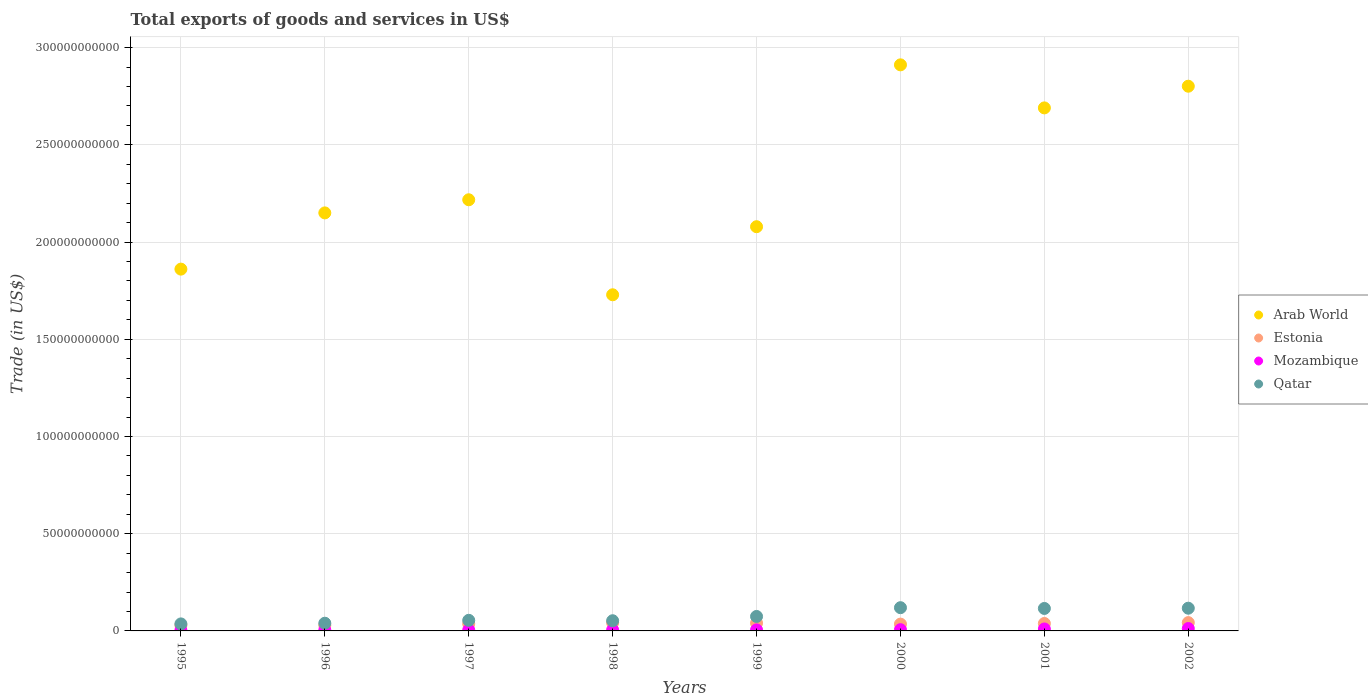How many different coloured dotlines are there?
Provide a succinct answer. 4. What is the total exports of goods and services in Mozambique in 2000?
Your answer should be compact. 6.44e+08. Across all years, what is the maximum total exports of goods and services in Estonia?
Keep it short and to the point. 4.27e+09. Across all years, what is the minimum total exports of goods and services in Mozambique?
Provide a succinct answer. 3.33e+08. In which year was the total exports of goods and services in Estonia minimum?
Your response must be concise. 1996. What is the total total exports of goods and services in Qatar in the graph?
Offer a terse response. 6.09e+1. What is the difference between the total exports of goods and services in Arab World in 1995 and that in 1996?
Give a very brief answer. -2.89e+1. What is the difference between the total exports of goods and services in Arab World in 2002 and the total exports of goods and services in Qatar in 1999?
Ensure brevity in your answer.  2.73e+11. What is the average total exports of goods and services in Estonia per year?
Your answer should be compact. 3.67e+09. In the year 1999, what is the difference between the total exports of goods and services in Qatar and total exports of goods and services in Mozambique?
Your answer should be very brief. 6.90e+09. In how many years, is the total exports of goods and services in Arab World greater than 110000000000 US$?
Offer a terse response. 8. What is the ratio of the total exports of goods and services in Qatar in 2000 to that in 2001?
Your answer should be compact. 1.03. What is the difference between the highest and the second highest total exports of goods and services in Arab World?
Ensure brevity in your answer.  1.10e+1. What is the difference between the highest and the lowest total exports of goods and services in Arab World?
Provide a succinct answer. 1.18e+11. Does the total exports of goods and services in Mozambique monotonically increase over the years?
Your response must be concise. Yes. Is the total exports of goods and services in Mozambique strictly greater than the total exports of goods and services in Estonia over the years?
Ensure brevity in your answer.  No. Is the total exports of goods and services in Mozambique strictly less than the total exports of goods and services in Qatar over the years?
Provide a succinct answer. Yes. What is the difference between two consecutive major ticks on the Y-axis?
Give a very brief answer. 5.00e+1. How many legend labels are there?
Make the answer very short. 4. How are the legend labels stacked?
Offer a very short reply. Vertical. What is the title of the graph?
Make the answer very short. Total exports of goods and services in US$. What is the label or title of the Y-axis?
Offer a very short reply. Trade (in US$). What is the Trade (in US$) of Arab World in 1995?
Your response must be concise. 1.86e+11. What is the Trade (in US$) of Estonia in 1995?
Your answer should be very brief. 2.97e+09. What is the Trade (in US$) in Mozambique in 1995?
Your answer should be compact. 3.33e+08. What is the Trade (in US$) in Qatar in 1995?
Provide a short and direct response. 3.61e+09. What is the Trade (in US$) of Arab World in 1996?
Make the answer very short. 2.15e+11. What is the Trade (in US$) in Estonia in 1996?
Keep it short and to the point. 2.93e+09. What is the Trade (in US$) of Mozambique in 1996?
Offer a very short reply. 4.64e+08. What is the Trade (in US$) of Qatar in 1996?
Your response must be concise. 3.96e+09. What is the Trade (in US$) in Arab World in 1997?
Give a very brief answer. 2.22e+11. What is the Trade (in US$) in Estonia in 1997?
Keep it short and to the point. 3.63e+09. What is the Trade (in US$) in Mozambique in 1997?
Your response must be concise. 5.08e+08. What is the Trade (in US$) in Qatar in 1997?
Provide a succinct answer. 5.45e+09. What is the Trade (in US$) of Arab World in 1998?
Make the answer very short. 1.73e+11. What is the Trade (in US$) in Estonia in 1998?
Your answer should be very brief. 4.18e+09. What is the Trade (in US$) of Mozambique in 1998?
Your answer should be compact. 5.33e+08. What is the Trade (in US$) of Qatar in 1998?
Provide a succinct answer. 5.24e+09. What is the Trade (in US$) of Arab World in 1999?
Provide a succinct answer. 2.08e+11. What is the Trade (in US$) of Estonia in 1999?
Provide a short and direct response. 4.02e+09. What is the Trade (in US$) of Mozambique in 1999?
Keep it short and to the point. 5.39e+08. What is the Trade (in US$) of Qatar in 1999?
Make the answer very short. 7.44e+09. What is the Trade (in US$) in Arab World in 2000?
Your answer should be very brief. 2.91e+11. What is the Trade (in US$) in Estonia in 2000?
Your answer should be compact. 3.50e+09. What is the Trade (in US$) in Mozambique in 2000?
Provide a succinct answer. 6.44e+08. What is the Trade (in US$) in Qatar in 2000?
Provide a short and direct response. 1.19e+1. What is the Trade (in US$) in Arab World in 2001?
Provide a short and direct response. 2.69e+11. What is the Trade (in US$) of Estonia in 2001?
Offer a terse response. 3.83e+09. What is the Trade (in US$) of Mozambique in 2001?
Offer a very short reply. 1.01e+09. What is the Trade (in US$) in Qatar in 2001?
Provide a short and direct response. 1.16e+1. What is the Trade (in US$) of Arab World in 2002?
Ensure brevity in your answer.  2.80e+11. What is the Trade (in US$) in Estonia in 2002?
Offer a very short reply. 4.27e+09. What is the Trade (in US$) of Mozambique in 2002?
Your answer should be very brief. 1.23e+09. What is the Trade (in US$) of Qatar in 2002?
Ensure brevity in your answer.  1.17e+1. Across all years, what is the maximum Trade (in US$) of Arab World?
Give a very brief answer. 2.91e+11. Across all years, what is the maximum Trade (in US$) of Estonia?
Your answer should be very brief. 4.27e+09. Across all years, what is the maximum Trade (in US$) of Mozambique?
Keep it short and to the point. 1.23e+09. Across all years, what is the maximum Trade (in US$) in Qatar?
Keep it short and to the point. 1.19e+1. Across all years, what is the minimum Trade (in US$) in Arab World?
Keep it short and to the point. 1.73e+11. Across all years, what is the minimum Trade (in US$) of Estonia?
Make the answer very short. 2.93e+09. Across all years, what is the minimum Trade (in US$) in Mozambique?
Offer a terse response. 3.33e+08. Across all years, what is the minimum Trade (in US$) in Qatar?
Offer a terse response. 3.61e+09. What is the total Trade (in US$) of Arab World in the graph?
Offer a very short reply. 1.84e+12. What is the total Trade (in US$) in Estonia in the graph?
Make the answer very short. 2.93e+1. What is the total Trade (in US$) in Mozambique in the graph?
Make the answer very short. 5.26e+09. What is the total Trade (in US$) in Qatar in the graph?
Your answer should be compact. 6.09e+1. What is the difference between the Trade (in US$) in Arab World in 1995 and that in 1996?
Offer a very short reply. -2.89e+1. What is the difference between the Trade (in US$) of Estonia in 1995 and that in 1996?
Make the answer very short. 3.47e+07. What is the difference between the Trade (in US$) in Mozambique in 1995 and that in 1996?
Offer a terse response. -1.31e+08. What is the difference between the Trade (in US$) of Qatar in 1995 and that in 1996?
Ensure brevity in your answer.  -3.53e+08. What is the difference between the Trade (in US$) of Arab World in 1995 and that in 1997?
Provide a succinct answer. -3.57e+1. What is the difference between the Trade (in US$) in Estonia in 1995 and that in 1997?
Provide a short and direct response. -6.60e+08. What is the difference between the Trade (in US$) of Mozambique in 1995 and that in 1997?
Keep it short and to the point. -1.74e+08. What is the difference between the Trade (in US$) of Qatar in 1995 and that in 1997?
Keep it short and to the point. -1.85e+09. What is the difference between the Trade (in US$) of Arab World in 1995 and that in 1998?
Provide a succinct answer. 1.32e+1. What is the difference between the Trade (in US$) in Estonia in 1995 and that in 1998?
Make the answer very short. -1.21e+09. What is the difference between the Trade (in US$) of Mozambique in 1995 and that in 1998?
Your response must be concise. -1.99e+08. What is the difference between the Trade (in US$) in Qatar in 1995 and that in 1998?
Offer a very short reply. -1.63e+09. What is the difference between the Trade (in US$) of Arab World in 1995 and that in 1999?
Ensure brevity in your answer.  -2.18e+1. What is the difference between the Trade (in US$) in Estonia in 1995 and that in 1999?
Ensure brevity in your answer.  -1.05e+09. What is the difference between the Trade (in US$) of Mozambique in 1995 and that in 1999?
Keep it short and to the point. -2.06e+08. What is the difference between the Trade (in US$) of Qatar in 1995 and that in 1999?
Provide a short and direct response. -3.83e+09. What is the difference between the Trade (in US$) in Arab World in 1995 and that in 2000?
Make the answer very short. -1.05e+11. What is the difference between the Trade (in US$) in Estonia in 1995 and that in 2000?
Make the answer very short. -5.37e+08. What is the difference between the Trade (in US$) in Mozambique in 1995 and that in 2000?
Offer a very short reply. -3.10e+08. What is the difference between the Trade (in US$) in Qatar in 1995 and that in 2000?
Your answer should be compact. -8.34e+09. What is the difference between the Trade (in US$) of Arab World in 1995 and that in 2001?
Provide a succinct answer. -8.29e+1. What is the difference between the Trade (in US$) of Estonia in 1995 and that in 2001?
Your answer should be very brief. -8.64e+08. What is the difference between the Trade (in US$) in Mozambique in 1995 and that in 2001?
Your response must be concise. -6.73e+08. What is the difference between the Trade (in US$) in Qatar in 1995 and that in 2001?
Provide a succinct answer. -7.95e+09. What is the difference between the Trade (in US$) in Arab World in 1995 and that in 2002?
Your response must be concise. -9.41e+1. What is the difference between the Trade (in US$) of Estonia in 1995 and that in 2002?
Offer a very short reply. -1.30e+09. What is the difference between the Trade (in US$) of Mozambique in 1995 and that in 2002?
Your answer should be compact. -8.95e+08. What is the difference between the Trade (in US$) in Qatar in 1995 and that in 2002?
Keep it short and to the point. -8.08e+09. What is the difference between the Trade (in US$) in Arab World in 1996 and that in 1997?
Keep it short and to the point. -6.75e+09. What is the difference between the Trade (in US$) of Estonia in 1996 and that in 1997?
Make the answer very short. -6.95e+08. What is the difference between the Trade (in US$) in Mozambique in 1996 and that in 1997?
Give a very brief answer. -4.33e+07. What is the difference between the Trade (in US$) of Qatar in 1996 and that in 1997?
Keep it short and to the point. -1.49e+09. What is the difference between the Trade (in US$) in Arab World in 1996 and that in 1998?
Your answer should be compact. 4.21e+1. What is the difference between the Trade (in US$) in Estonia in 1996 and that in 1998?
Provide a short and direct response. -1.25e+09. What is the difference between the Trade (in US$) in Mozambique in 1996 and that in 1998?
Your answer should be very brief. -6.84e+07. What is the difference between the Trade (in US$) in Qatar in 1996 and that in 1998?
Your answer should be compact. -1.28e+09. What is the difference between the Trade (in US$) in Arab World in 1996 and that in 1999?
Offer a very short reply. 7.10e+09. What is the difference between the Trade (in US$) in Estonia in 1996 and that in 1999?
Give a very brief answer. -1.09e+09. What is the difference between the Trade (in US$) in Mozambique in 1996 and that in 1999?
Offer a terse response. -7.48e+07. What is the difference between the Trade (in US$) in Qatar in 1996 and that in 1999?
Your response must be concise. -3.48e+09. What is the difference between the Trade (in US$) of Arab World in 1996 and that in 2000?
Keep it short and to the point. -7.61e+1. What is the difference between the Trade (in US$) in Estonia in 1996 and that in 2000?
Offer a terse response. -5.72e+08. What is the difference between the Trade (in US$) in Mozambique in 1996 and that in 2000?
Ensure brevity in your answer.  -1.79e+08. What is the difference between the Trade (in US$) of Qatar in 1996 and that in 2000?
Ensure brevity in your answer.  -7.99e+09. What is the difference between the Trade (in US$) of Arab World in 1996 and that in 2001?
Your answer should be compact. -5.40e+1. What is the difference between the Trade (in US$) of Estonia in 1996 and that in 2001?
Your answer should be very brief. -8.98e+08. What is the difference between the Trade (in US$) of Mozambique in 1996 and that in 2001?
Keep it short and to the point. -5.42e+08. What is the difference between the Trade (in US$) of Qatar in 1996 and that in 2001?
Make the answer very short. -7.60e+09. What is the difference between the Trade (in US$) in Arab World in 1996 and that in 2002?
Give a very brief answer. -6.52e+1. What is the difference between the Trade (in US$) in Estonia in 1996 and that in 2002?
Make the answer very short. -1.34e+09. What is the difference between the Trade (in US$) in Mozambique in 1996 and that in 2002?
Ensure brevity in your answer.  -7.64e+08. What is the difference between the Trade (in US$) in Qatar in 1996 and that in 2002?
Your answer should be very brief. -7.72e+09. What is the difference between the Trade (in US$) in Arab World in 1997 and that in 1998?
Provide a succinct answer. 4.89e+1. What is the difference between the Trade (in US$) of Estonia in 1997 and that in 1998?
Your answer should be very brief. -5.50e+08. What is the difference between the Trade (in US$) in Mozambique in 1997 and that in 1998?
Ensure brevity in your answer.  -2.51e+07. What is the difference between the Trade (in US$) of Qatar in 1997 and that in 1998?
Offer a terse response. 2.15e+08. What is the difference between the Trade (in US$) in Arab World in 1997 and that in 1999?
Your answer should be compact. 1.39e+1. What is the difference between the Trade (in US$) in Estonia in 1997 and that in 1999?
Make the answer very short. -3.94e+08. What is the difference between the Trade (in US$) in Mozambique in 1997 and that in 1999?
Provide a short and direct response. -3.15e+07. What is the difference between the Trade (in US$) of Qatar in 1997 and that in 1999?
Offer a terse response. -1.99e+09. What is the difference between the Trade (in US$) of Arab World in 1997 and that in 2000?
Ensure brevity in your answer.  -6.94e+1. What is the difference between the Trade (in US$) in Estonia in 1997 and that in 2000?
Offer a very short reply. 1.23e+08. What is the difference between the Trade (in US$) in Mozambique in 1997 and that in 2000?
Keep it short and to the point. -1.36e+08. What is the difference between the Trade (in US$) in Qatar in 1997 and that in 2000?
Provide a short and direct response. -6.49e+09. What is the difference between the Trade (in US$) in Arab World in 1997 and that in 2001?
Your answer should be very brief. -4.73e+1. What is the difference between the Trade (in US$) of Estonia in 1997 and that in 2001?
Ensure brevity in your answer.  -2.03e+08. What is the difference between the Trade (in US$) of Mozambique in 1997 and that in 2001?
Offer a very short reply. -4.99e+08. What is the difference between the Trade (in US$) in Qatar in 1997 and that in 2001?
Provide a short and direct response. -6.10e+09. What is the difference between the Trade (in US$) of Arab World in 1997 and that in 2002?
Give a very brief answer. -5.84e+1. What is the difference between the Trade (in US$) of Estonia in 1997 and that in 2002?
Make the answer very short. -6.42e+08. What is the difference between the Trade (in US$) in Mozambique in 1997 and that in 2002?
Your answer should be compact. -7.21e+08. What is the difference between the Trade (in US$) in Qatar in 1997 and that in 2002?
Your answer should be compact. -6.23e+09. What is the difference between the Trade (in US$) in Arab World in 1998 and that in 1999?
Keep it short and to the point. -3.50e+1. What is the difference between the Trade (in US$) of Estonia in 1998 and that in 1999?
Provide a short and direct response. 1.56e+08. What is the difference between the Trade (in US$) of Mozambique in 1998 and that in 1999?
Your answer should be very brief. -6.35e+06. What is the difference between the Trade (in US$) of Qatar in 1998 and that in 1999?
Offer a terse response. -2.20e+09. What is the difference between the Trade (in US$) in Arab World in 1998 and that in 2000?
Make the answer very short. -1.18e+11. What is the difference between the Trade (in US$) of Estonia in 1998 and that in 2000?
Provide a short and direct response. 6.74e+08. What is the difference between the Trade (in US$) in Mozambique in 1998 and that in 2000?
Your answer should be very brief. -1.11e+08. What is the difference between the Trade (in US$) in Qatar in 1998 and that in 2000?
Your response must be concise. -6.71e+09. What is the difference between the Trade (in US$) of Arab World in 1998 and that in 2001?
Your answer should be very brief. -9.61e+1. What is the difference between the Trade (in US$) in Estonia in 1998 and that in 2001?
Offer a very short reply. 3.47e+08. What is the difference between the Trade (in US$) in Mozambique in 1998 and that in 2001?
Your response must be concise. -4.74e+08. What is the difference between the Trade (in US$) of Qatar in 1998 and that in 2001?
Give a very brief answer. -6.32e+09. What is the difference between the Trade (in US$) of Arab World in 1998 and that in 2002?
Your answer should be very brief. -1.07e+11. What is the difference between the Trade (in US$) in Estonia in 1998 and that in 2002?
Ensure brevity in your answer.  -9.21e+07. What is the difference between the Trade (in US$) of Mozambique in 1998 and that in 2002?
Keep it short and to the point. -6.96e+08. What is the difference between the Trade (in US$) of Qatar in 1998 and that in 2002?
Make the answer very short. -6.44e+09. What is the difference between the Trade (in US$) of Arab World in 1999 and that in 2000?
Provide a short and direct response. -8.32e+1. What is the difference between the Trade (in US$) in Estonia in 1999 and that in 2000?
Offer a very short reply. 5.18e+08. What is the difference between the Trade (in US$) of Mozambique in 1999 and that in 2000?
Ensure brevity in your answer.  -1.05e+08. What is the difference between the Trade (in US$) of Qatar in 1999 and that in 2000?
Provide a succinct answer. -4.51e+09. What is the difference between the Trade (in US$) in Arab World in 1999 and that in 2001?
Offer a terse response. -6.11e+1. What is the difference between the Trade (in US$) in Estonia in 1999 and that in 2001?
Ensure brevity in your answer.  1.91e+08. What is the difference between the Trade (in US$) of Mozambique in 1999 and that in 2001?
Give a very brief answer. -4.68e+08. What is the difference between the Trade (in US$) of Qatar in 1999 and that in 2001?
Offer a terse response. -4.12e+09. What is the difference between the Trade (in US$) in Arab World in 1999 and that in 2002?
Your answer should be very brief. -7.23e+1. What is the difference between the Trade (in US$) in Estonia in 1999 and that in 2002?
Your answer should be very brief. -2.48e+08. What is the difference between the Trade (in US$) of Mozambique in 1999 and that in 2002?
Ensure brevity in your answer.  -6.89e+08. What is the difference between the Trade (in US$) in Qatar in 1999 and that in 2002?
Offer a very short reply. -4.24e+09. What is the difference between the Trade (in US$) in Arab World in 2000 and that in 2001?
Provide a succinct answer. 2.21e+1. What is the difference between the Trade (in US$) in Estonia in 2000 and that in 2001?
Ensure brevity in your answer.  -3.27e+08. What is the difference between the Trade (in US$) of Mozambique in 2000 and that in 2001?
Keep it short and to the point. -3.63e+08. What is the difference between the Trade (in US$) of Qatar in 2000 and that in 2001?
Give a very brief answer. 3.93e+08. What is the difference between the Trade (in US$) of Arab World in 2000 and that in 2002?
Ensure brevity in your answer.  1.10e+1. What is the difference between the Trade (in US$) of Estonia in 2000 and that in 2002?
Keep it short and to the point. -7.66e+08. What is the difference between the Trade (in US$) of Mozambique in 2000 and that in 2002?
Your answer should be compact. -5.85e+08. What is the difference between the Trade (in US$) of Qatar in 2000 and that in 2002?
Your answer should be compact. 2.65e+08. What is the difference between the Trade (in US$) of Arab World in 2001 and that in 2002?
Provide a succinct answer. -1.12e+1. What is the difference between the Trade (in US$) in Estonia in 2001 and that in 2002?
Offer a very short reply. -4.39e+08. What is the difference between the Trade (in US$) of Mozambique in 2001 and that in 2002?
Offer a very short reply. -2.22e+08. What is the difference between the Trade (in US$) in Qatar in 2001 and that in 2002?
Provide a short and direct response. -1.28e+08. What is the difference between the Trade (in US$) of Arab World in 1995 and the Trade (in US$) of Estonia in 1996?
Provide a short and direct response. 1.83e+11. What is the difference between the Trade (in US$) in Arab World in 1995 and the Trade (in US$) in Mozambique in 1996?
Ensure brevity in your answer.  1.86e+11. What is the difference between the Trade (in US$) of Arab World in 1995 and the Trade (in US$) of Qatar in 1996?
Provide a succinct answer. 1.82e+11. What is the difference between the Trade (in US$) in Estonia in 1995 and the Trade (in US$) in Mozambique in 1996?
Offer a very short reply. 2.50e+09. What is the difference between the Trade (in US$) in Estonia in 1995 and the Trade (in US$) in Qatar in 1996?
Offer a very short reply. -9.94e+08. What is the difference between the Trade (in US$) of Mozambique in 1995 and the Trade (in US$) of Qatar in 1996?
Keep it short and to the point. -3.63e+09. What is the difference between the Trade (in US$) in Arab World in 1995 and the Trade (in US$) in Estonia in 1997?
Your response must be concise. 1.82e+11. What is the difference between the Trade (in US$) of Arab World in 1995 and the Trade (in US$) of Mozambique in 1997?
Make the answer very short. 1.86e+11. What is the difference between the Trade (in US$) in Arab World in 1995 and the Trade (in US$) in Qatar in 1997?
Your answer should be compact. 1.81e+11. What is the difference between the Trade (in US$) in Estonia in 1995 and the Trade (in US$) in Mozambique in 1997?
Provide a succinct answer. 2.46e+09. What is the difference between the Trade (in US$) of Estonia in 1995 and the Trade (in US$) of Qatar in 1997?
Offer a very short reply. -2.49e+09. What is the difference between the Trade (in US$) in Mozambique in 1995 and the Trade (in US$) in Qatar in 1997?
Your answer should be very brief. -5.12e+09. What is the difference between the Trade (in US$) in Arab World in 1995 and the Trade (in US$) in Estonia in 1998?
Offer a very short reply. 1.82e+11. What is the difference between the Trade (in US$) of Arab World in 1995 and the Trade (in US$) of Mozambique in 1998?
Ensure brevity in your answer.  1.86e+11. What is the difference between the Trade (in US$) of Arab World in 1995 and the Trade (in US$) of Qatar in 1998?
Provide a succinct answer. 1.81e+11. What is the difference between the Trade (in US$) of Estonia in 1995 and the Trade (in US$) of Mozambique in 1998?
Offer a very short reply. 2.43e+09. What is the difference between the Trade (in US$) of Estonia in 1995 and the Trade (in US$) of Qatar in 1998?
Ensure brevity in your answer.  -2.27e+09. What is the difference between the Trade (in US$) of Mozambique in 1995 and the Trade (in US$) of Qatar in 1998?
Provide a succinct answer. -4.91e+09. What is the difference between the Trade (in US$) of Arab World in 1995 and the Trade (in US$) of Estonia in 1999?
Provide a short and direct response. 1.82e+11. What is the difference between the Trade (in US$) in Arab World in 1995 and the Trade (in US$) in Mozambique in 1999?
Your answer should be compact. 1.86e+11. What is the difference between the Trade (in US$) in Arab World in 1995 and the Trade (in US$) in Qatar in 1999?
Make the answer very short. 1.79e+11. What is the difference between the Trade (in US$) in Estonia in 1995 and the Trade (in US$) in Mozambique in 1999?
Your response must be concise. 2.43e+09. What is the difference between the Trade (in US$) in Estonia in 1995 and the Trade (in US$) in Qatar in 1999?
Make the answer very short. -4.47e+09. What is the difference between the Trade (in US$) in Mozambique in 1995 and the Trade (in US$) in Qatar in 1999?
Provide a short and direct response. -7.11e+09. What is the difference between the Trade (in US$) in Arab World in 1995 and the Trade (in US$) in Estonia in 2000?
Offer a terse response. 1.83e+11. What is the difference between the Trade (in US$) in Arab World in 1995 and the Trade (in US$) in Mozambique in 2000?
Offer a terse response. 1.85e+11. What is the difference between the Trade (in US$) of Arab World in 1995 and the Trade (in US$) of Qatar in 2000?
Keep it short and to the point. 1.74e+11. What is the difference between the Trade (in US$) in Estonia in 1995 and the Trade (in US$) in Mozambique in 2000?
Your answer should be very brief. 2.32e+09. What is the difference between the Trade (in US$) of Estonia in 1995 and the Trade (in US$) of Qatar in 2000?
Provide a succinct answer. -8.98e+09. What is the difference between the Trade (in US$) in Mozambique in 1995 and the Trade (in US$) in Qatar in 2000?
Offer a terse response. -1.16e+1. What is the difference between the Trade (in US$) in Arab World in 1995 and the Trade (in US$) in Estonia in 2001?
Keep it short and to the point. 1.82e+11. What is the difference between the Trade (in US$) of Arab World in 1995 and the Trade (in US$) of Mozambique in 2001?
Provide a short and direct response. 1.85e+11. What is the difference between the Trade (in US$) of Arab World in 1995 and the Trade (in US$) of Qatar in 2001?
Your response must be concise. 1.75e+11. What is the difference between the Trade (in US$) in Estonia in 1995 and the Trade (in US$) in Mozambique in 2001?
Your response must be concise. 1.96e+09. What is the difference between the Trade (in US$) in Estonia in 1995 and the Trade (in US$) in Qatar in 2001?
Your answer should be compact. -8.59e+09. What is the difference between the Trade (in US$) in Mozambique in 1995 and the Trade (in US$) in Qatar in 2001?
Ensure brevity in your answer.  -1.12e+1. What is the difference between the Trade (in US$) in Arab World in 1995 and the Trade (in US$) in Estonia in 2002?
Offer a very short reply. 1.82e+11. What is the difference between the Trade (in US$) of Arab World in 1995 and the Trade (in US$) of Mozambique in 2002?
Ensure brevity in your answer.  1.85e+11. What is the difference between the Trade (in US$) of Arab World in 1995 and the Trade (in US$) of Qatar in 2002?
Your answer should be compact. 1.74e+11. What is the difference between the Trade (in US$) in Estonia in 1995 and the Trade (in US$) in Mozambique in 2002?
Offer a terse response. 1.74e+09. What is the difference between the Trade (in US$) of Estonia in 1995 and the Trade (in US$) of Qatar in 2002?
Offer a terse response. -8.72e+09. What is the difference between the Trade (in US$) of Mozambique in 1995 and the Trade (in US$) of Qatar in 2002?
Offer a very short reply. -1.14e+1. What is the difference between the Trade (in US$) of Arab World in 1996 and the Trade (in US$) of Estonia in 1997?
Provide a short and direct response. 2.11e+11. What is the difference between the Trade (in US$) of Arab World in 1996 and the Trade (in US$) of Mozambique in 1997?
Give a very brief answer. 2.14e+11. What is the difference between the Trade (in US$) in Arab World in 1996 and the Trade (in US$) in Qatar in 1997?
Keep it short and to the point. 2.10e+11. What is the difference between the Trade (in US$) in Estonia in 1996 and the Trade (in US$) in Mozambique in 1997?
Provide a short and direct response. 2.43e+09. What is the difference between the Trade (in US$) in Estonia in 1996 and the Trade (in US$) in Qatar in 1997?
Your answer should be very brief. -2.52e+09. What is the difference between the Trade (in US$) of Mozambique in 1996 and the Trade (in US$) of Qatar in 1997?
Your response must be concise. -4.99e+09. What is the difference between the Trade (in US$) in Arab World in 1996 and the Trade (in US$) in Estonia in 1998?
Provide a succinct answer. 2.11e+11. What is the difference between the Trade (in US$) in Arab World in 1996 and the Trade (in US$) in Mozambique in 1998?
Give a very brief answer. 2.14e+11. What is the difference between the Trade (in US$) of Arab World in 1996 and the Trade (in US$) of Qatar in 1998?
Provide a short and direct response. 2.10e+11. What is the difference between the Trade (in US$) in Estonia in 1996 and the Trade (in US$) in Mozambique in 1998?
Provide a succinct answer. 2.40e+09. What is the difference between the Trade (in US$) in Estonia in 1996 and the Trade (in US$) in Qatar in 1998?
Make the answer very short. -2.31e+09. What is the difference between the Trade (in US$) of Mozambique in 1996 and the Trade (in US$) of Qatar in 1998?
Provide a short and direct response. -4.78e+09. What is the difference between the Trade (in US$) in Arab World in 1996 and the Trade (in US$) in Estonia in 1999?
Make the answer very short. 2.11e+11. What is the difference between the Trade (in US$) in Arab World in 1996 and the Trade (in US$) in Mozambique in 1999?
Provide a short and direct response. 2.14e+11. What is the difference between the Trade (in US$) of Arab World in 1996 and the Trade (in US$) of Qatar in 1999?
Give a very brief answer. 2.08e+11. What is the difference between the Trade (in US$) of Estonia in 1996 and the Trade (in US$) of Mozambique in 1999?
Ensure brevity in your answer.  2.39e+09. What is the difference between the Trade (in US$) of Estonia in 1996 and the Trade (in US$) of Qatar in 1999?
Ensure brevity in your answer.  -4.51e+09. What is the difference between the Trade (in US$) of Mozambique in 1996 and the Trade (in US$) of Qatar in 1999?
Your response must be concise. -6.98e+09. What is the difference between the Trade (in US$) of Arab World in 1996 and the Trade (in US$) of Estonia in 2000?
Ensure brevity in your answer.  2.11e+11. What is the difference between the Trade (in US$) in Arab World in 1996 and the Trade (in US$) in Mozambique in 2000?
Give a very brief answer. 2.14e+11. What is the difference between the Trade (in US$) in Arab World in 1996 and the Trade (in US$) in Qatar in 2000?
Make the answer very short. 2.03e+11. What is the difference between the Trade (in US$) of Estonia in 1996 and the Trade (in US$) of Mozambique in 2000?
Your answer should be compact. 2.29e+09. What is the difference between the Trade (in US$) in Estonia in 1996 and the Trade (in US$) in Qatar in 2000?
Offer a terse response. -9.02e+09. What is the difference between the Trade (in US$) in Mozambique in 1996 and the Trade (in US$) in Qatar in 2000?
Offer a very short reply. -1.15e+1. What is the difference between the Trade (in US$) in Arab World in 1996 and the Trade (in US$) in Estonia in 2001?
Your answer should be very brief. 2.11e+11. What is the difference between the Trade (in US$) in Arab World in 1996 and the Trade (in US$) in Mozambique in 2001?
Give a very brief answer. 2.14e+11. What is the difference between the Trade (in US$) in Arab World in 1996 and the Trade (in US$) in Qatar in 2001?
Ensure brevity in your answer.  2.03e+11. What is the difference between the Trade (in US$) of Estonia in 1996 and the Trade (in US$) of Mozambique in 2001?
Your answer should be very brief. 1.93e+09. What is the difference between the Trade (in US$) in Estonia in 1996 and the Trade (in US$) in Qatar in 2001?
Provide a short and direct response. -8.62e+09. What is the difference between the Trade (in US$) in Mozambique in 1996 and the Trade (in US$) in Qatar in 2001?
Provide a succinct answer. -1.11e+1. What is the difference between the Trade (in US$) of Arab World in 1996 and the Trade (in US$) of Estonia in 2002?
Make the answer very short. 2.11e+11. What is the difference between the Trade (in US$) in Arab World in 1996 and the Trade (in US$) in Mozambique in 2002?
Your response must be concise. 2.14e+11. What is the difference between the Trade (in US$) of Arab World in 1996 and the Trade (in US$) of Qatar in 2002?
Your answer should be compact. 2.03e+11. What is the difference between the Trade (in US$) of Estonia in 1996 and the Trade (in US$) of Mozambique in 2002?
Ensure brevity in your answer.  1.70e+09. What is the difference between the Trade (in US$) of Estonia in 1996 and the Trade (in US$) of Qatar in 2002?
Give a very brief answer. -8.75e+09. What is the difference between the Trade (in US$) of Mozambique in 1996 and the Trade (in US$) of Qatar in 2002?
Make the answer very short. -1.12e+1. What is the difference between the Trade (in US$) of Arab World in 1997 and the Trade (in US$) of Estonia in 1998?
Offer a very short reply. 2.18e+11. What is the difference between the Trade (in US$) in Arab World in 1997 and the Trade (in US$) in Mozambique in 1998?
Offer a very short reply. 2.21e+11. What is the difference between the Trade (in US$) in Arab World in 1997 and the Trade (in US$) in Qatar in 1998?
Your answer should be very brief. 2.17e+11. What is the difference between the Trade (in US$) in Estonia in 1997 and the Trade (in US$) in Mozambique in 1998?
Your answer should be very brief. 3.10e+09. What is the difference between the Trade (in US$) of Estonia in 1997 and the Trade (in US$) of Qatar in 1998?
Give a very brief answer. -1.61e+09. What is the difference between the Trade (in US$) in Mozambique in 1997 and the Trade (in US$) in Qatar in 1998?
Provide a short and direct response. -4.73e+09. What is the difference between the Trade (in US$) in Arab World in 1997 and the Trade (in US$) in Estonia in 1999?
Make the answer very short. 2.18e+11. What is the difference between the Trade (in US$) in Arab World in 1997 and the Trade (in US$) in Mozambique in 1999?
Give a very brief answer. 2.21e+11. What is the difference between the Trade (in US$) in Arab World in 1997 and the Trade (in US$) in Qatar in 1999?
Your response must be concise. 2.14e+11. What is the difference between the Trade (in US$) of Estonia in 1997 and the Trade (in US$) of Mozambique in 1999?
Offer a terse response. 3.09e+09. What is the difference between the Trade (in US$) of Estonia in 1997 and the Trade (in US$) of Qatar in 1999?
Make the answer very short. -3.81e+09. What is the difference between the Trade (in US$) of Mozambique in 1997 and the Trade (in US$) of Qatar in 1999?
Ensure brevity in your answer.  -6.93e+09. What is the difference between the Trade (in US$) of Arab World in 1997 and the Trade (in US$) of Estonia in 2000?
Your answer should be compact. 2.18e+11. What is the difference between the Trade (in US$) of Arab World in 1997 and the Trade (in US$) of Mozambique in 2000?
Give a very brief answer. 2.21e+11. What is the difference between the Trade (in US$) in Arab World in 1997 and the Trade (in US$) in Qatar in 2000?
Your answer should be very brief. 2.10e+11. What is the difference between the Trade (in US$) of Estonia in 1997 and the Trade (in US$) of Mozambique in 2000?
Ensure brevity in your answer.  2.98e+09. What is the difference between the Trade (in US$) in Estonia in 1997 and the Trade (in US$) in Qatar in 2000?
Keep it short and to the point. -8.32e+09. What is the difference between the Trade (in US$) of Mozambique in 1997 and the Trade (in US$) of Qatar in 2000?
Provide a succinct answer. -1.14e+1. What is the difference between the Trade (in US$) in Arab World in 1997 and the Trade (in US$) in Estonia in 2001?
Make the answer very short. 2.18e+11. What is the difference between the Trade (in US$) of Arab World in 1997 and the Trade (in US$) of Mozambique in 2001?
Ensure brevity in your answer.  2.21e+11. What is the difference between the Trade (in US$) of Arab World in 1997 and the Trade (in US$) of Qatar in 2001?
Your response must be concise. 2.10e+11. What is the difference between the Trade (in US$) of Estonia in 1997 and the Trade (in US$) of Mozambique in 2001?
Offer a very short reply. 2.62e+09. What is the difference between the Trade (in US$) in Estonia in 1997 and the Trade (in US$) in Qatar in 2001?
Your answer should be very brief. -7.93e+09. What is the difference between the Trade (in US$) of Mozambique in 1997 and the Trade (in US$) of Qatar in 2001?
Provide a succinct answer. -1.10e+1. What is the difference between the Trade (in US$) of Arab World in 1997 and the Trade (in US$) of Estonia in 2002?
Your response must be concise. 2.17e+11. What is the difference between the Trade (in US$) of Arab World in 1997 and the Trade (in US$) of Mozambique in 2002?
Give a very brief answer. 2.21e+11. What is the difference between the Trade (in US$) of Arab World in 1997 and the Trade (in US$) of Qatar in 2002?
Give a very brief answer. 2.10e+11. What is the difference between the Trade (in US$) of Estonia in 1997 and the Trade (in US$) of Mozambique in 2002?
Your answer should be compact. 2.40e+09. What is the difference between the Trade (in US$) of Estonia in 1997 and the Trade (in US$) of Qatar in 2002?
Keep it short and to the point. -8.06e+09. What is the difference between the Trade (in US$) of Mozambique in 1997 and the Trade (in US$) of Qatar in 2002?
Ensure brevity in your answer.  -1.12e+1. What is the difference between the Trade (in US$) of Arab World in 1998 and the Trade (in US$) of Estonia in 1999?
Your answer should be very brief. 1.69e+11. What is the difference between the Trade (in US$) in Arab World in 1998 and the Trade (in US$) in Mozambique in 1999?
Provide a succinct answer. 1.72e+11. What is the difference between the Trade (in US$) in Arab World in 1998 and the Trade (in US$) in Qatar in 1999?
Your answer should be compact. 1.65e+11. What is the difference between the Trade (in US$) in Estonia in 1998 and the Trade (in US$) in Mozambique in 1999?
Make the answer very short. 3.64e+09. What is the difference between the Trade (in US$) in Estonia in 1998 and the Trade (in US$) in Qatar in 1999?
Your answer should be compact. -3.26e+09. What is the difference between the Trade (in US$) in Mozambique in 1998 and the Trade (in US$) in Qatar in 1999?
Ensure brevity in your answer.  -6.91e+09. What is the difference between the Trade (in US$) in Arab World in 1998 and the Trade (in US$) in Estonia in 2000?
Offer a very short reply. 1.69e+11. What is the difference between the Trade (in US$) of Arab World in 1998 and the Trade (in US$) of Mozambique in 2000?
Keep it short and to the point. 1.72e+11. What is the difference between the Trade (in US$) in Arab World in 1998 and the Trade (in US$) in Qatar in 2000?
Your answer should be very brief. 1.61e+11. What is the difference between the Trade (in US$) in Estonia in 1998 and the Trade (in US$) in Mozambique in 2000?
Give a very brief answer. 3.53e+09. What is the difference between the Trade (in US$) of Estonia in 1998 and the Trade (in US$) of Qatar in 2000?
Your response must be concise. -7.77e+09. What is the difference between the Trade (in US$) in Mozambique in 1998 and the Trade (in US$) in Qatar in 2000?
Give a very brief answer. -1.14e+1. What is the difference between the Trade (in US$) in Arab World in 1998 and the Trade (in US$) in Estonia in 2001?
Make the answer very short. 1.69e+11. What is the difference between the Trade (in US$) of Arab World in 1998 and the Trade (in US$) of Mozambique in 2001?
Ensure brevity in your answer.  1.72e+11. What is the difference between the Trade (in US$) in Arab World in 1998 and the Trade (in US$) in Qatar in 2001?
Provide a succinct answer. 1.61e+11. What is the difference between the Trade (in US$) in Estonia in 1998 and the Trade (in US$) in Mozambique in 2001?
Ensure brevity in your answer.  3.17e+09. What is the difference between the Trade (in US$) of Estonia in 1998 and the Trade (in US$) of Qatar in 2001?
Keep it short and to the point. -7.38e+09. What is the difference between the Trade (in US$) in Mozambique in 1998 and the Trade (in US$) in Qatar in 2001?
Provide a short and direct response. -1.10e+1. What is the difference between the Trade (in US$) in Arab World in 1998 and the Trade (in US$) in Estonia in 2002?
Give a very brief answer. 1.69e+11. What is the difference between the Trade (in US$) in Arab World in 1998 and the Trade (in US$) in Mozambique in 2002?
Keep it short and to the point. 1.72e+11. What is the difference between the Trade (in US$) of Arab World in 1998 and the Trade (in US$) of Qatar in 2002?
Offer a very short reply. 1.61e+11. What is the difference between the Trade (in US$) of Estonia in 1998 and the Trade (in US$) of Mozambique in 2002?
Offer a very short reply. 2.95e+09. What is the difference between the Trade (in US$) in Estonia in 1998 and the Trade (in US$) in Qatar in 2002?
Ensure brevity in your answer.  -7.51e+09. What is the difference between the Trade (in US$) in Mozambique in 1998 and the Trade (in US$) in Qatar in 2002?
Ensure brevity in your answer.  -1.12e+1. What is the difference between the Trade (in US$) of Arab World in 1999 and the Trade (in US$) of Estonia in 2000?
Your response must be concise. 2.04e+11. What is the difference between the Trade (in US$) of Arab World in 1999 and the Trade (in US$) of Mozambique in 2000?
Ensure brevity in your answer.  2.07e+11. What is the difference between the Trade (in US$) in Arab World in 1999 and the Trade (in US$) in Qatar in 2000?
Provide a short and direct response. 1.96e+11. What is the difference between the Trade (in US$) in Estonia in 1999 and the Trade (in US$) in Mozambique in 2000?
Offer a terse response. 3.38e+09. What is the difference between the Trade (in US$) in Estonia in 1999 and the Trade (in US$) in Qatar in 2000?
Your answer should be very brief. -7.93e+09. What is the difference between the Trade (in US$) in Mozambique in 1999 and the Trade (in US$) in Qatar in 2000?
Offer a terse response. -1.14e+1. What is the difference between the Trade (in US$) in Arab World in 1999 and the Trade (in US$) in Estonia in 2001?
Your answer should be very brief. 2.04e+11. What is the difference between the Trade (in US$) in Arab World in 1999 and the Trade (in US$) in Mozambique in 2001?
Give a very brief answer. 2.07e+11. What is the difference between the Trade (in US$) of Arab World in 1999 and the Trade (in US$) of Qatar in 2001?
Offer a terse response. 1.96e+11. What is the difference between the Trade (in US$) in Estonia in 1999 and the Trade (in US$) in Mozambique in 2001?
Offer a very short reply. 3.02e+09. What is the difference between the Trade (in US$) in Estonia in 1999 and the Trade (in US$) in Qatar in 2001?
Offer a terse response. -7.53e+09. What is the difference between the Trade (in US$) in Mozambique in 1999 and the Trade (in US$) in Qatar in 2001?
Give a very brief answer. -1.10e+1. What is the difference between the Trade (in US$) in Arab World in 1999 and the Trade (in US$) in Estonia in 2002?
Ensure brevity in your answer.  2.04e+11. What is the difference between the Trade (in US$) of Arab World in 1999 and the Trade (in US$) of Mozambique in 2002?
Give a very brief answer. 2.07e+11. What is the difference between the Trade (in US$) of Arab World in 1999 and the Trade (in US$) of Qatar in 2002?
Ensure brevity in your answer.  1.96e+11. What is the difference between the Trade (in US$) of Estonia in 1999 and the Trade (in US$) of Mozambique in 2002?
Give a very brief answer. 2.79e+09. What is the difference between the Trade (in US$) in Estonia in 1999 and the Trade (in US$) in Qatar in 2002?
Offer a terse response. -7.66e+09. What is the difference between the Trade (in US$) in Mozambique in 1999 and the Trade (in US$) in Qatar in 2002?
Offer a very short reply. -1.11e+1. What is the difference between the Trade (in US$) in Arab World in 2000 and the Trade (in US$) in Estonia in 2001?
Make the answer very short. 2.87e+11. What is the difference between the Trade (in US$) in Arab World in 2000 and the Trade (in US$) in Mozambique in 2001?
Offer a very short reply. 2.90e+11. What is the difference between the Trade (in US$) of Arab World in 2000 and the Trade (in US$) of Qatar in 2001?
Your answer should be very brief. 2.80e+11. What is the difference between the Trade (in US$) in Estonia in 2000 and the Trade (in US$) in Mozambique in 2001?
Provide a succinct answer. 2.50e+09. What is the difference between the Trade (in US$) in Estonia in 2000 and the Trade (in US$) in Qatar in 2001?
Your answer should be very brief. -8.05e+09. What is the difference between the Trade (in US$) of Mozambique in 2000 and the Trade (in US$) of Qatar in 2001?
Your answer should be compact. -1.09e+1. What is the difference between the Trade (in US$) in Arab World in 2000 and the Trade (in US$) in Estonia in 2002?
Offer a terse response. 2.87e+11. What is the difference between the Trade (in US$) in Arab World in 2000 and the Trade (in US$) in Mozambique in 2002?
Offer a very short reply. 2.90e+11. What is the difference between the Trade (in US$) in Arab World in 2000 and the Trade (in US$) in Qatar in 2002?
Your response must be concise. 2.79e+11. What is the difference between the Trade (in US$) of Estonia in 2000 and the Trade (in US$) of Mozambique in 2002?
Your answer should be very brief. 2.28e+09. What is the difference between the Trade (in US$) of Estonia in 2000 and the Trade (in US$) of Qatar in 2002?
Make the answer very short. -8.18e+09. What is the difference between the Trade (in US$) of Mozambique in 2000 and the Trade (in US$) of Qatar in 2002?
Your answer should be very brief. -1.10e+1. What is the difference between the Trade (in US$) in Arab World in 2001 and the Trade (in US$) in Estonia in 2002?
Offer a very short reply. 2.65e+11. What is the difference between the Trade (in US$) in Arab World in 2001 and the Trade (in US$) in Mozambique in 2002?
Offer a very short reply. 2.68e+11. What is the difference between the Trade (in US$) in Arab World in 2001 and the Trade (in US$) in Qatar in 2002?
Your answer should be very brief. 2.57e+11. What is the difference between the Trade (in US$) of Estonia in 2001 and the Trade (in US$) of Mozambique in 2002?
Your answer should be very brief. 2.60e+09. What is the difference between the Trade (in US$) of Estonia in 2001 and the Trade (in US$) of Qatar in 2002?
Ensure brevity in your answer.  -7.85e+09. What is the difference between the Trade (in US$) in Mozambique in 2001 and the Trade (in US$) in Qatar in 2002?
Provide a succinct answer. -1.07e+1. What is the average Trade (in US$) of Arab World per year?
Your answer should be very brief. 2.30e+11. What is the average Trade (in US$) of Estonia per year?
Offer a very short reply. 3.67e+09. What is the average Trade (in US$) in Mozambique per year?
Provide a short and direct response. 6.57e+08. What is the average Trade (in US$) of Qatar per year?
Keep it short and to the point. 7.61e+09. In the year 1995, what is the difference between the Trade (in US$) in Arab World and Trade (in US$) in Estonia?
Your answer should be compact. 1.83e+11. In the year 1995, what is the difference between the Trade (in US$) of Arab World and Trade (in US$) of Mozambique?
Provide a succinct answer. 1.86e+11. In the year 1995, what is the difference between the Trade (in US$) of Arab World and Trade (in US$) of Qatar?
Provide a short and direct response. 1.82e+11. In the year 1995, what is the difference between the Trade (in US$) in Estonia and Trade (in US$) in Mozambique?
Provide a succinct answer. 2.63e+09. In the year 1995, what is the difference between the Trade (in US$) in Estonia and Trade (in US$) in Qatar?
Provide a short and direct response. -6.41e+08. In the year 1995, what is the difference between the Trade (in US$) of Mozambique and Trade (in US$) of Qatar?
Provide a short and direct response. -3.28e+09. In the year 1996, what is the difference between the Trade (in US$) of Arab World and Trade (in US$) of Estonia?
Your answer should be compact. 2.12e+11. In the year 1996, what is the difference between the Trade (in US$) in Arab World and Trade (in US$) in Mozambique?
Offer a terse response. 2.15e+11. In the year 1996, what is the difference between the Trade (in US$) in Arab World and Trade (in US$) in Qatar?
Your answer should be very brief. 2.11e+11. In the year 1996, what is the difference between the Trade (in US$) in Estonia and Trade (in US$) in Mozambique?
Give a very brief answer. 2.47e+09. In the year 1996, what is the difference between the Trade (in US$) in Estonia and Trade (in US$) in Qatar?
Ensure brevity in your answer.  -1.03e+09. In the year 1996, what is the difference between the Trade (in US$) in Mozambique and Trade (in US$) in Qatar?
Your response must be concise. -3.50e+09. In the year 1997, what is the difference between the Trade (in US$) in Arab World and Trade (in US$) in Estonia?
Your response must be concise. 2.18e+11. In the year 1997, what is the difference between the Trade (in US$) in Arab World and Trade (in US$) in Mozambique?
Offer a very short reply. 2.21e+11. In the year 1997, what is the difference between the Trade (in US$) of Arab World and Trade (in US$) of Qatar?
Give a very brief answer. 2.16e+11. In the year 1997, what is the difference between the Trade (in US$) in Estonia and Trade (in US$) in Mozambique?
Your answer should be very brief. 3.12e+09. In the year 1997, what is the difference between the Trade (in US$) of Estonia and Trade (in US$) of Qatar?
Your response must be concise. -1.83e+09. In the year 1997, what is the difference between the Trade (in US$) of Mozambique and Trade (in US$) of Qatar?
Give a very brief answer. -4.95e+09. In the year 1998, what is the difference between the Trade (in US$) of Arab World and Trade (in US$) of Estonia?
Provide a short and direct response. 1.69e+11. In the year 1998, what is the difference between the Trade (in US$) of Arab World and Trade (in US$) of Mozambique?
Ensure brevity in your answer.  1.72e+11. In the year 1998, what is the difference between the Trade (in US$) of Arab World and Trade (in US$) of Qatar?
Your answer should be compact. 1.68e+11. In the year 1998, what is the difference between the Trade (in US$) in Estonia and Trade (in US$) in Mozambique?
Ensure brevity in your answer.  3.65e+09. In the year 1998, what is the difference between the Trade (in US$) of Estonia and Trade (in US$) of Qatar?
Your response must be concise. -1.06e+09. In the year 1998, what is the difference between the Trade (in US$) in Mozambique and Trade (in US$) in Qatar?
Provide a succinct answer. -4.71e+09. In the year 1999, what is the difference between the Trade (in US$) of Arab World and Trade (in US$) of Estonia?
Keep it short and to the point. 2.04e+11. In the year 1999, what is the difference between the Trade (in US$) in Arab World and Trade (in US$) in Mozambique?
Keep it short and to the point. 2.07e+11. In the year 1999, what is the difference between the Trade (in US$) in Arab World and Trade (in US$) in Qatar?
Give a very brief answer. 2.00e+11. In the year 1999, what is the difference between the Trade (in US$) of Estonia and Trade (in US$) of Mozambique?
Make the answer very short. 3.48e+09. In the year 1999, what is the difference between the Trade (in US$) in Estonia and Trade (in US$) in Qatar?
Your answer should be very brief. -3.42e+09. In the year 1999, what is the difference between the Trade (in US$) of Mozambique and Trade (in US$) of Qatar?
Keep it short and to the point. -6.90e+09. In the year 2000, what is the difference between the Trade (in US$) of Arab World and Trade (in US$) of Estonia?
Make the answer very short. 2.88e+11. In the year 2000, what is the difference between the Trade (in US$) of Arab World and Trade (in US$) of Mozambique?
Offer a terse response. 2.90e+11. In the year 2000, what is the difference between the Trade (in US$) of Arab World and Trade (in US$) of Qatar?
Offer a very short reply. 2.79e+11. In the year 2000, what is the difference between the Trade (in US$) in Estonia and Trade (in US$) in Mozambique?
Keep it short and to the point. 2.86e+09. In the year 2000, what is the difference between the Trade (in US$) of Estonia and Trade (in US$) of Qatar?
Provide a short and direct response. -8.44e+09. In the year 2000, what is the difference between the Trade (in US$) in Mozambique and Trade (in US$) in Qatar?
Keep it short and to the point. -1.13e+1. In the year 2001, what is the difference between the Trade (in US$) in Arab World and Trade (in US$) in Estonia?
Your answer should be very brief. 2.65e+11. In the year 2001, what is the difference between the Trade (in US$) in Arab World and Trade (in US$) in Mozambique?
Provide a short and direct response. 2.68e+11. In the year 2001, what is the difference between the Trade (in US$) in Arab World and Trade (in US$) in Qatar?
Provide a succinct answer. 2.57e+11. In the year 2001, what is the difference between the Trade (in US$) in Estonia and Trade (in US$) in Mozambique?
Keep it short and to the point. 2.82e+09. In the year 2001, what is the difference between the Trade (in US$) of Estonia and Trade (in US$) of Qatar?
Your response must be concise. -7.73e+09. In the year 2001, what is the difference between the Trade (in US$) of Mozambique and Trade (in US$) of Qatar?
Your answer should be very brief. -1.05e+1. In the year 2002, what is the difference between the Trade (in US$) of Arab World and Trade (in US$) of Estonia?
Offer a very short reply. 2.76e+11. In the year 2002, what is the difference between the Trade (in US$) of Arab World and Trade (in US$) of Mozambique?
Offer a terse response. 2.79e+11. In the year 2002, what is the difference between the Trade (in US$) in Arab World and Trade (in US$) in Qatar?
Make the answer very short. 2.68e+11. In the year 2002, what is the difference between the Trade (in US$) of Estonia and Trade (in US$) of Mozambique?
Your answer should be very brief. 3.04e+09. In the year 2002, what is the difference between the Trade (in US$) in Estonia and Trade (in US$) in Qatar?
Offer a very short reply. -7.41e+09. In the year 2002, what is the difference between the Trade (in US$) of Mozambique and Trade (in US$) of Qatar?
Offer a terse response. -1.05e+1. What is the ratio of the Trade (in US$) in Arab World in 1995 to that in 1996?
Provide a succinct answer. 0.87. What is the ratio of the Trade (in US$) of Estonia in 1995 to that in 1996?
Your answer should be very brief. 1.01. What is the ratio of the Trade (in US$) of Mozambique in 1995 to that in 1996?
Provide a succinct answer. 0.72. What is the ratio of the Trade (in US$) in Qatar in 1995 to that in 1996?
Your response must be concise. 0.91. What is the ratio of the Trade (in US$) of Arab World in 1995 to that in 1997?
Offer a terse response. 0.84. What is the ratio of the Trade (in US$) of Estonia in 1995 to that in 1997?
Offer a very short reply. 0.82. What is the ratio of the Trade (in US$) of Mozambique in 1995 to that in 1997?
Ensure brevity in your answer.  0.66. What is the ratio of the Trade (in US$) in Qatar in 1995 to that in 1997?
Provide a short and direct response. 0.66. What is the ratio of the Trade (in US$) of Arab World in 1995 to that in 1998?
Your response must be concise. 1.08. What is the ratio of the Trade (in US$) in Estonia in 1995 to that in 1998?
Ensure brevity in your answer.  0.71. What is the ratio of the Trade (in US$) in Mozambique in 1995 to that in 1998?
Offer a very short reply. 0.63. What is the ratio of the Trade (in US$) in Qatar in 1995 to that in 1998?
Keep it short and to the point. 0.69. What is the ratio of the Trade (in US$) of Arab World in 1995 to that in 1999?
Keep it short and to the point. 0.9. What is the ratio of the Trade (in US$) of Estonia in 1995 to that in 1999?
Offer a very short reply. 0.74. What is the ratio of the Trade (in US$) of Mozambique in 1995 to that in 1999?
Your response must be concise. 0.62. What is the ratio of the Trade (in US$) in Qatar in 1995 to that in 1999?
Provide a short and direct response. 0.48. What is the ratio of the Trade (in US$) of Arab World in 1995 to that in 2000?
Keep it short and to the point. 0.64. What is the ratio of the Trade (in US$) of Estonia in 1995 to that in 2000?
Make the answer very short. 0.85. What is the ratio of the Trade (in US$) in Mozambique in 1995 to that in 2000?
Make the answer very short. 0.52. What is the ratio of the Trade (in US$) in Qatar in 1995 to that in 2000?
Your answer should be compact. 0.3. What is the ratio of the Trade (in US$) in Arab World in 1995 to that in 2001?
Give a very brief answer. 0.69. What is the ratio of the Trade (in US$) of Estonia in 1995 to that in 2001?
Offer a terse response. 0.77. What is the ratio of the Trade (in US$) of Mozambique in 1995 to that in 2001?
Your response must be concise. 0.33. What is the ratio of the Trade (in US$) of Qatar in 1995 to that in 2001?
Your response must be concise. 0.31. What is the ratio of the Trade (in US$) of Arab World in 1995 to that in 2002?
Your answer should be compact. 0.66. What is the ratio of the Trade (in US$) in Estonia in 1995 to that in 2002?
Offer a terse response. 0.69. What is the ratio of the Trade (in US$) of Mozambique in 1995 to that in 2002?
Your answer should be compact. 0.27. What is the ratio of the Trade (in US$) of Qatar in 1995 to that in 2002?
Offer a very short reply. 0.31. What is the ratio of the Trade (in US$) of Arab World in 1996 to that in 1997?
Your response must be concise. 0.97. What is the ratio of the Trade (in US$) in Estonia in 1996 to that in 1997?
Offer a very short reply. 0.81. What is the ratio of the Trade (in US$) of Mozambique in 1996 to that in 1997?
Offer a very short reply. 0.91. What is the ratio of the Trade (in US$) in Qatar in 1996 to that in 1997?
Give a very brief answer. 0.73. What is the ratio of the Trade (in US$) in Arab World in 1996 to that in 1998?
Your answer should be compact. 1.24. What is the ratio of the Trade (in US$) of Estonia in 1996 to that in 1998?
Your response must be concise. 0.7. What is the ratio of the Trade (in US$) of Mozambique in 1996 to that in 1998?
Offer a very short reply. 0.87. What is the ratio of the Trade (in US$) in Qatar in 1996 to that in 1998?
Give a very brief answer. 0.76. What is the ratio of the Trade (in US$) of Arab World in 1996 to that in 1999?
Provide a short and direct response. 1.03. What is the ratio of the Trade (in US$) of Estonia in 1996 to that in 1999?
Offer a terse response. 0.73. What is the ratio of the Trade (in US$) of Mozambique in 1996 to that in 1999?
Provide a succinct answer. 0.86. What is the ratio of the Trade (in US$) in Qatar in 1996 to that in 1999?
Ensure brevity in your answer.  0.53. What is the ratio of the Trade (in US$) in Arab World in 1996 to that in 2000?
Give a very brief answer. 0.74. What is the ratio of the Trade (in US$) in Estonia in 1996 to that in 2000?
Offer a very short reply. 0.84. What is the ratio of the Trade (in US$) of Mozambique in 1996 to that in 2000?
Your response must be concise. 0.72. What is the ratio of the Trade (in US$) in Qatar in 1996 to that in 2000?
Your answer should be compact. 0.33. What is the ratio of the Trade (in US$) of Arab World in 1996 to that in 2001?
Offer a terse response. 0.8. What is the ratio of the Trade (in US$) of Estonia in 1996 to that in 2001?
Offer a terse response. 0.77. What is the ratio of the Trade (in US$) of Mozambique in 1996 to that in 2001?
Make the answer very short. 0.46. What is the ratio of the Trade (in US$) of Qatar in 1996 to that in 2001?
Ensure brevity in your answer.  0.34. What is the ratio of the Trade (in US$) of Arab World in 1996 to that in 2002?
Your answer should be very brief. 0.77. What is the ratio of the Trade (in US$) in Estonia in 1996 to that in 2002?
Your response must be concise. 0.69. What is the ratio of the Trade (in US$) of Mozambique in 1996 to that in 2002?
Your answer should be compact. 0.38. What is the ratio of the Trade (in US$) of Qatar in 1996 to that in 2002?
Your answer should be very brief. 0.34. What is the ratio of the Trade (in US$) of Arab World in 1997 to that in 1998?
Your answer should be compact. 1.28. What is the ratio of the Trade (in US$) in Estonia in 1997 to that in 1998?
Provide a short and direct response. 0.87. What is the ratio of the Trade (in US$) of Mozambique in 1997 to that in 1998?
Offer a very short reply. 0.95. What is the ratio of the Trade (in US$) of Qatar in 1997 to that in 1998?
Ensure brevity in your answer.  1.04. What is the ratio of the Trade (in US$) in Arab World in 1997 to that in 1999?
Your answer should be compact. 1.07. What is the ratio of the Trade (in US$) of Estonia in 1997 to that in 1999?
Keep it short and to the point. 0.9. What is the ratio of the Trade (in US$) of Mozambique in 1997 to that in 1999?
Your answer should be compact. 0.94. What is the ratio of the Trade (in US$) in Qatar in 1997 to that in 1999?
Your response must be concise. 0.73. What is the ratio of the Trade (in US$) in Arab World in 1997 to that in 2000?
Provide a short and direct response. 0.76. What is the ratio of the Trade (in US$) in Estonia in 1997 to that in 2000?
Provide a succinct answer. 1.04. What is the ratio of the Trade (in US$) of Mozambique in 1997 to that in 2000?
Keep it short and to the point. 0.79. What is the ratio of the Trade (in US$) in Qatar in 1997 to that in 2000?
Your answer should be compact. 0.46. What is the ratio of the Trade (in US$) of Arab World in 1997 to that in 2001?
Offer a very short reply. 0.82. What is the ratio of the Trade (in US$) in Estonia in 1997 to that in 2001?
Offer a terse response. 0.95. What is the ratio of the Trade (in US$) in Mozambique in 1997 to that in 2001?
Your answer should be very brief. 0.5. What is the ratio of the Trade (in US$) of Qatar in 1997 to that in 2001?
Make the answer very short. 0.47. What is the ratio of the Trade (in US$) of Arab World in 1997 to that in 2002?
Provide a succinct answer. 0.79. What is the ratio of the Trade (in US$) of Estonia in 1997 to that in 2002?
Make the answer very short. 0.85. What is the ratio of the Trade (in US$) in Mozambique in 1997 to that in 2002?
Your response must be concise. 0.41. What is the ratio of the Trade (in US$) in Qatar in 1997 to that in 2002?
Offer a terse response. 0.47. What is the ratio of the Trade (in US$) of Arab World in 1998 to that in 1999?
Your response must be concise. 0.83. What is the ratio of the Trade (in US$) of Estonia in 1998 to that in 1999?
Ensure brevity in your answer.  1.04. What is the ratio of the Trade (in US$) in Mozambique in 1998 to that in 1999?
Provide a short and direct response. 0.99. What is the ratio of the Trade (in US$) in Qatar in 1998 to that in 1999?
Give a very brief answer. 0.7. What is the ratio of the Trade (in US$) in Arab World in 1998 to that in 2000?
Your answer should be very brief. 0.59. What is the ratio of the Trade (in US$) of Estonia in 1998 to that in 2000?
Give a very brief answer. 1.19. What is the ratio of the Trade (in US$) in Mozambique in 1998 to that in 2000?
Provide a succinct answer. 0.83. What is the ratio of the Trade (in US$) in Qatar in 1998 to that in 2000?
Make the answer very short. 0.44. What is the ratio of the Trade (in US$) of Arab World in 1998 to that in 2001?
Give a very brief answer. 0.64. What is the ratio of the Trade (in US$) in Estonia in 1998 to that in 2001?
Ensure brevity in your answer.  1.09. What is the ratio of the Trade (in US$) in Mozambique in 1998 to that in 2001?
Offer a very short reply. 0.53. What is the ratio of the Trade (in US$) in Qatar in 1998 to that in 2001?
Give a very brief answer. 0.45. What is the ratio of the Trade (in US$) of Arab World in 1998 to that in 2002?
Make the answer very short. 0.62. What is the ratio of the Trade (in US$) in Estonia in 1998 to that in 2002?
Your answer should be very brief. 0.98. What is the ratio of the Trade (in US$) of Mozambique in 1998 to that in 2002?
Offer a very short reply. 0.43. What is the ratio of the Trade (in US$) of Qatar in 1998 to that in 2002?
Your response must be concise. 0.45. What is the ratio of the Trade (in US$) in Arab World in 1999 to that in 2000?
Keep it short and to the point. 0.71. What is the ratio of the Trade (in US$) in Estonia in 1999 to that in 2000?
Make the answer very short. 1.15. What is the ratio of the Trade (in US$) in Mozambique in 1999 to that in 2000?
Offer a very short reply. 0.84. What is the ratio of the Trade (in US$) in Qatar in 1999 to that in 2000?
Give a very brief answer. 0.62. What is the ratio of the Trade (in US$) in Arab World in 1999 to that in 2001?
Provide a succinct answer. 0.77. What is the ratio of the Trade (in US$) of Estonia in 1999 to that in 2001?
Provide a short and direct response. 1.05. What is the ratio of the Trade (in US$) of Mozambique in 1999 to that in 2001?
Your response must be concise. 0.54. What is the ratio of the Trade (in US$) of Qatar in 1999 to that in 2001?
Provide a succinct answer. 0.64. What is the ratio of the Trade (in US$) of Arab World in 1999 to that in 2002?
Make the answer very short. 0.74. What is the ratio of the Trade (in US$) in Estonia in 1999 to that in 2002?
Offer a very short reply. 0.94. What is the ratio of the Trade (in US$) in Mozambique in 1999 to that in 2002?
Your answer should be very brief. 0.44. What is the ratio of the Trade (in US$) in Qatar in 1999 to that in 2002?
Offer a terse response. 0.64. What is the ratio of the Trade (in US$) of Arab World in 2000 to that in 2001?
Make the answer very short. 1.08. What is the ratio of the Trade (in US$) of Estonia in 2000 to that in 2001?
Make the answer very short. 0.91. What is the ratio of the Trade (in US$) in Mozambique in 2000 to that in 2001?
Keep it short and to the point. 0.64. What is the ratio of the Trade (in US$) in Qatar in 2000 to that in 2001?
Make the answer very short. 1.03. What is the ratio of the Trade (in US$) in Arab World in 2000 to that in 2002?
Ensure brevity in your answer.  1.04. What is the ratio of the Trade (in US$) in Estonia in 2000 to that in 2002?
Make the answer very short. 0.82. What is the ratio of the Trade (in US$) in Mozambique in 2000 to that in 2002?
Your response must be concise. 0.52. What is the ratio of the Trade (in US$) in Qatar in 2000 to that in 2002?
Give a very brief answer. 1.02. What is the ratio of the Trade (in US$) of Arab World in 2001 to that in 2002?
Your answer should be very brief. 0.96. What is the ratio of the Trade (in US$) in Estonia in 2001 to that in 2002?
Provide a short and direct response. 0.9. What is the ratio of the Trade (in US$) of Mozambique in 2001 to that in 2002?
Your response must be concise. 0.82. What is the difference between the highest and the second highest Trade (in US$) of Arab World?
Offer a very short reply. 1.10e+1. What is the difference between the highest and the second highest Trade (in US$) in Estonia?
Ensure brevity in your answer.  9.21e+07. What is the difference between the highest and the second highest Trade (in US$) of Mozambique?
Make the answer very short. 2.22e+08. What is the difference between the highest and the second highest Trade (in US$) in Qatar?
Ensure brevity in your answer.  2.65e+08. What is the difference between the highest and the lowest Trade (in US$) in Arab World?
Your answer should be very brief. 1.18e+11. What is the difference between the highest and the lowest Trade (in US$) of Estonia?
Ensure brevity in your answer.  1.34e+09. What is the difference between the highest and the lowest Trade (in US$) of Mozambique?
Your response must be concise. 8.95e+08. What is the difference between the highest and the lowest Trade (in US$) in Qatar?
Offer a terse response. 8.34e+09. 